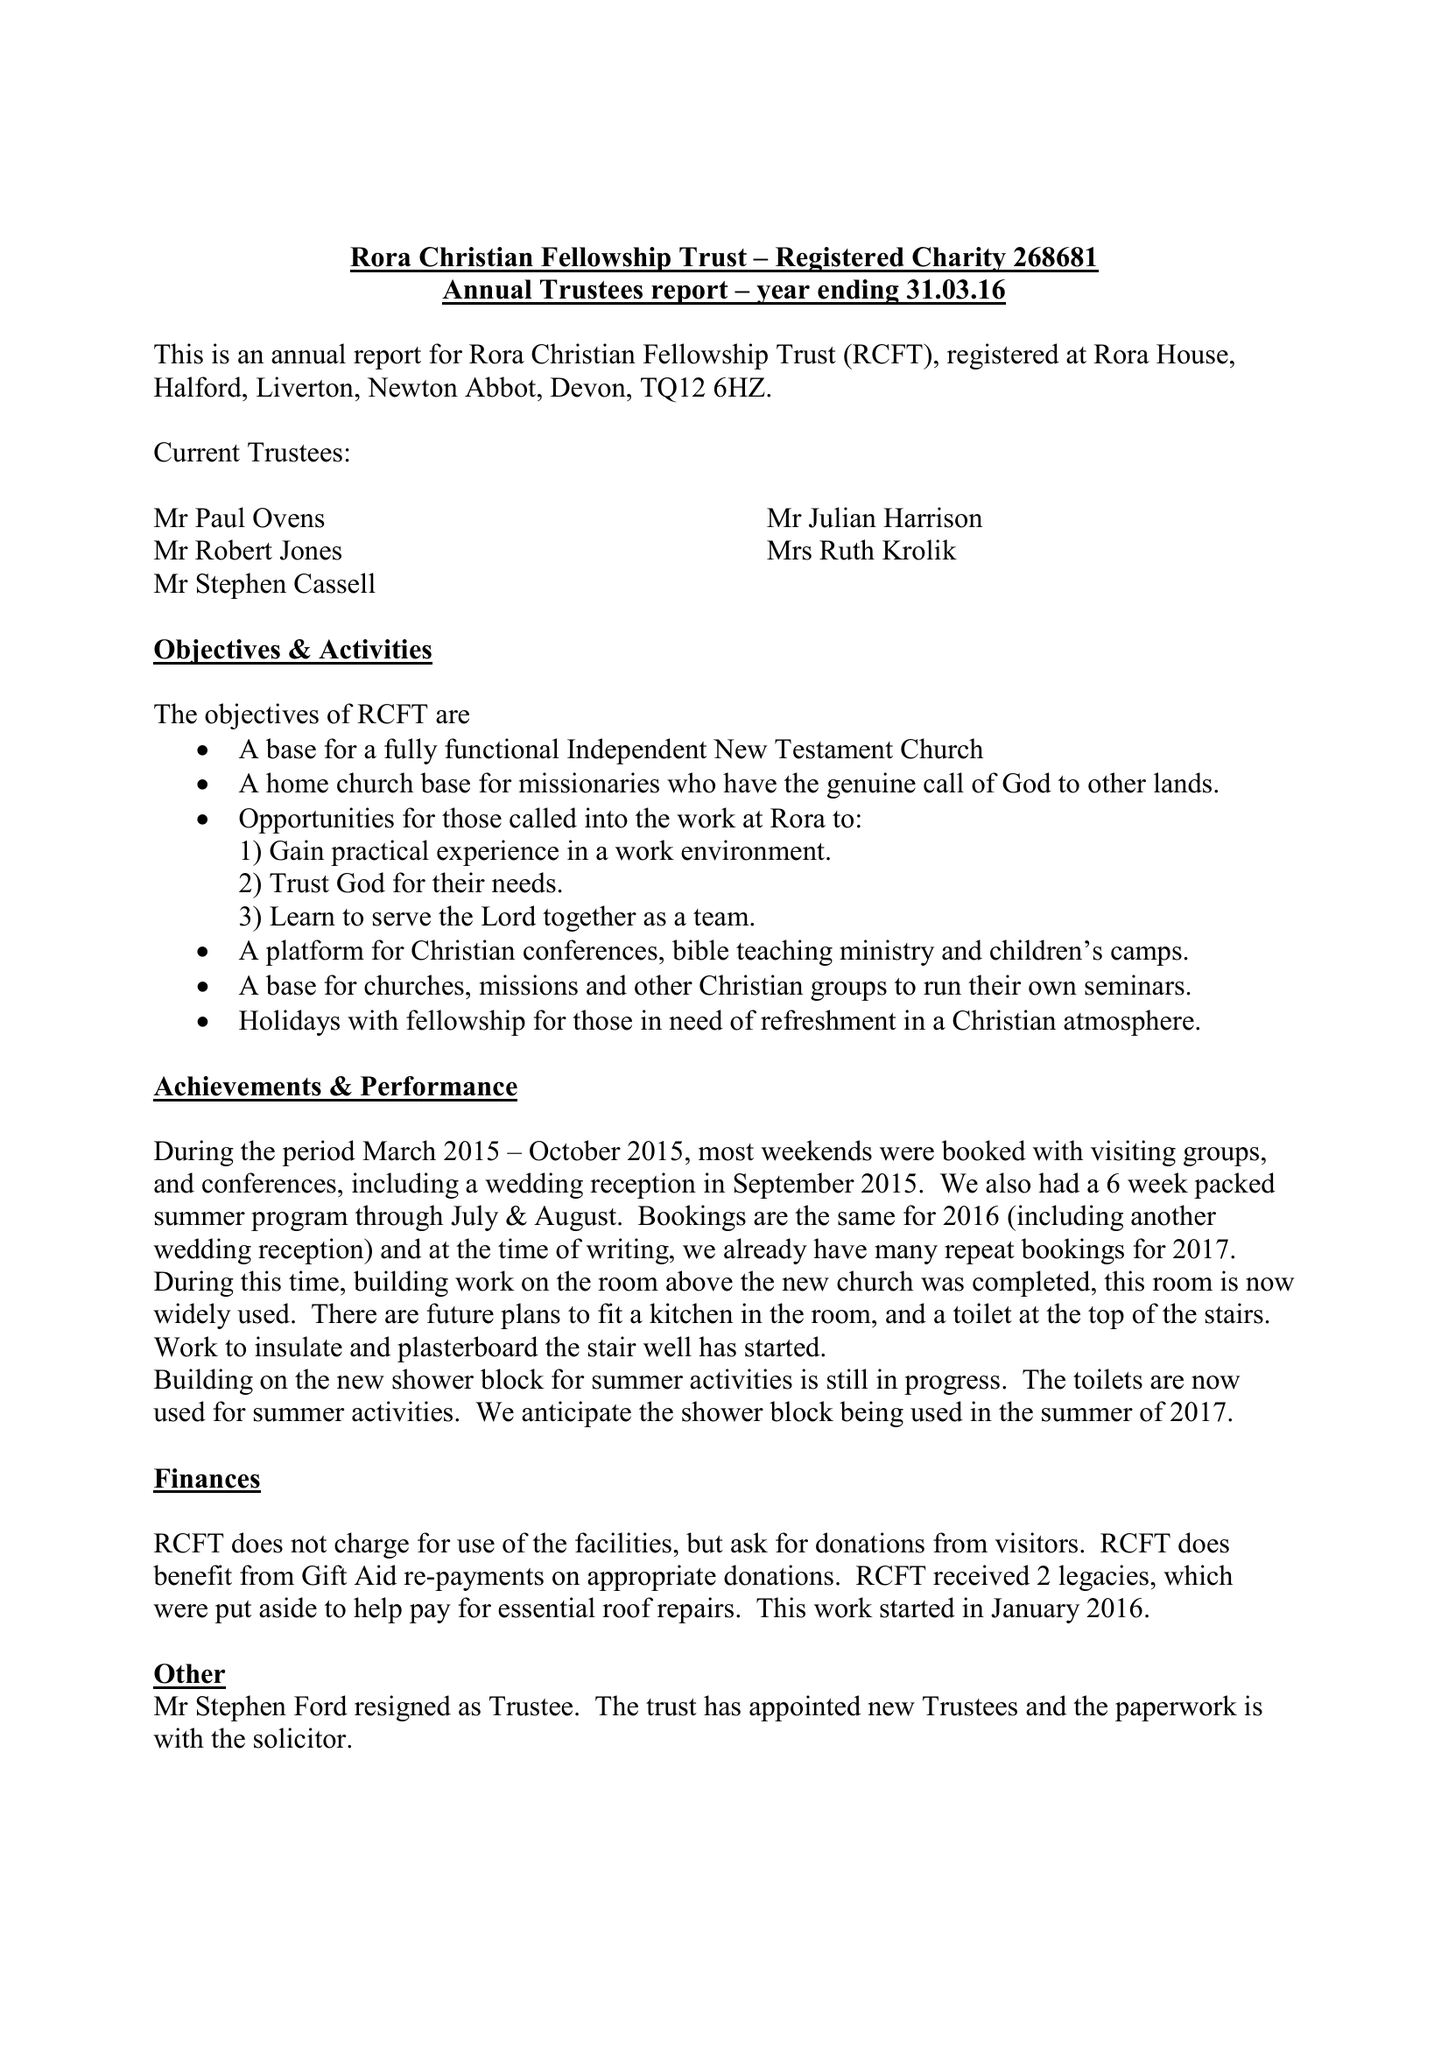What is the value for the address__postcode?
Answer the question using a single word or phrase. TQ12 6HZ 